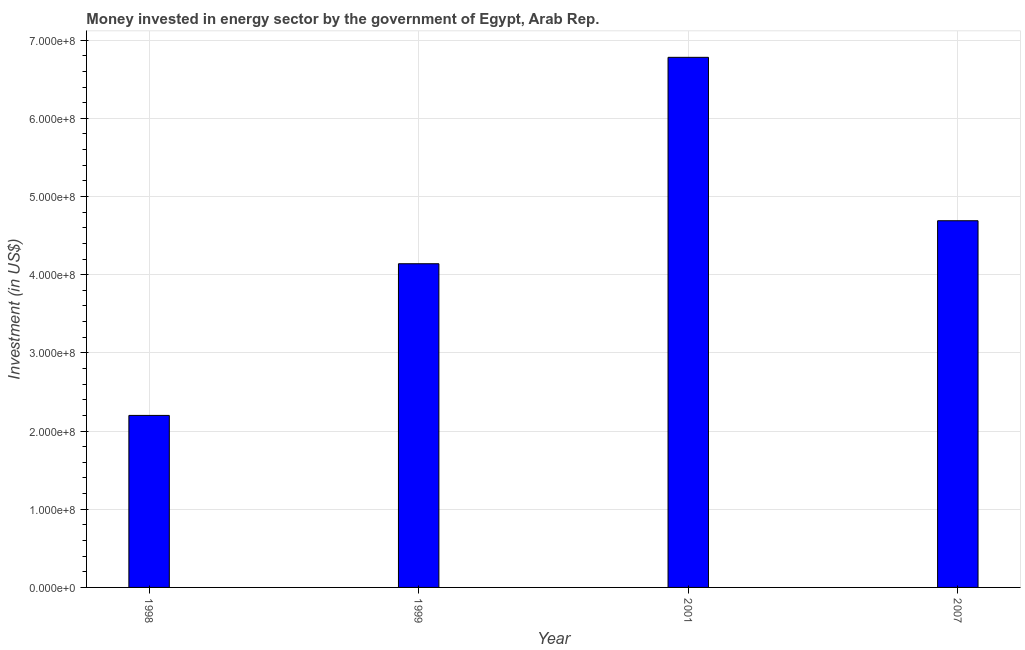What is the title of the graph?
Your response must be concise. Money invested in energy sector by the government of Egypt, Arab Rep. What is the label or title of the Y-axis?
Provide a succinct answer. Investment (in US$). What is the investment in energy in 1999?
Keep it short and to the point. 4.14e+08. Across all years, what is the maximum investment in energy?
Keep it short and to the point. 6.78e+08. Across all years, what is the minimum investment in energy?
Keep it short and to the point. 2.20e+08. What is the sum of the investment in energy?
Offer a terse response. 1.78e+09. What is the difference between the investment in energy in 1998 and 2001?
Make the answer very short. -4.58e+08. What is the average investment in energy per year?
Your answer should be very brief. 4.45e+08. What is the median investment in energy?
Offer a terse response. 4.42e+08. Do a majority of the years between 1999 and 1998 (inclusive) have investment in energy greater than 40000000 US$?
Give a very brief answer. No. What is the ratio of the investment in energy in 1999 to that in 2007?
Offer a very short reply. 0.88. Is the investment in energy in 2001 less than that in 2007?
Your answer should be very brief. No. Is the difference between the investment in energy in 1998 and 1999 greater than the difference between any two years?
Your answer should be very brief. No. What is the difference between the highest and the second highest investment in energy?
Provide a succinct answer. 2.09e+08. Is the sum of the investment in energy in 1998 and 1999 greater than the maximum investment in energy across all years?
Provide a succinct answer. No. What is the difference between the highest and the lowest investment in energy?
Offer a terse response. 4.58e+08. How many bars are there?
Offer a terse response. 4. How many years are there in the graph?
Provide a succinct answer. 4. What is the difference between two consecutive major ticks on the Y-axis?
Your response must be concise. 1.00e+08. What is the Investment (in US$) in 1998?
Offer a very short reply. 2.20e+08. What is the Investment (in US$) in 1999?
Offer a very short reply. 4.14e+08. What is the Investment (in US$) in 2001?
Provide a succinct answer. 6.78e+08. What is the Investment (in US$) of 2007?
Keep it short and to the point. 4.69e+08. What is the difference between the Investment (in US$) in 1998 and 1999?
Give a very brief answer. -1.94e+08. What is the difference between the Investment (in US$) in 1998 and 2001?
Offer a very short reply. -4.58e+08. What is the difference between the Investment (in US$) in 1998 and 2007?
Offer a very short reply. -2.49e+08. What is the difference between the Investment (in US$) in 1999 and 2001?
Give a very brief answer. -2.64e+08. What is the difference between the Investment (in US$) in 1999 and 2007?
Ensure brevity in your answer.  -5.50e+07. What is the difference between the Investment (in US$) in 2001 and 2007?
Ensure brevity in your answer.  2.09e+08. What is the ratio of the Investment (in US$) in 1998 to that in 1999?
Give a very brief answer. 0.53. What is the ratio of the Investment (in US$) in 1998 to that in 2001?
Offer a very short reply. 0.32. What is the ratio of the Investment (in US$) in 1998 to that in 2007?
Make the answer very short. 0.47. What is the ratio of the Investment (in US$) in 1999 to that in 2001?
Provide a short and direct response. 0.61. What is the ratio of the Investment (in US$) in 1999 to that in 2007?
Your answer should be very brief. 0.88. What is the ratio of the Investment (in US$) in 2001 to that in 2007?
Your answer should be compact. 1.45. 